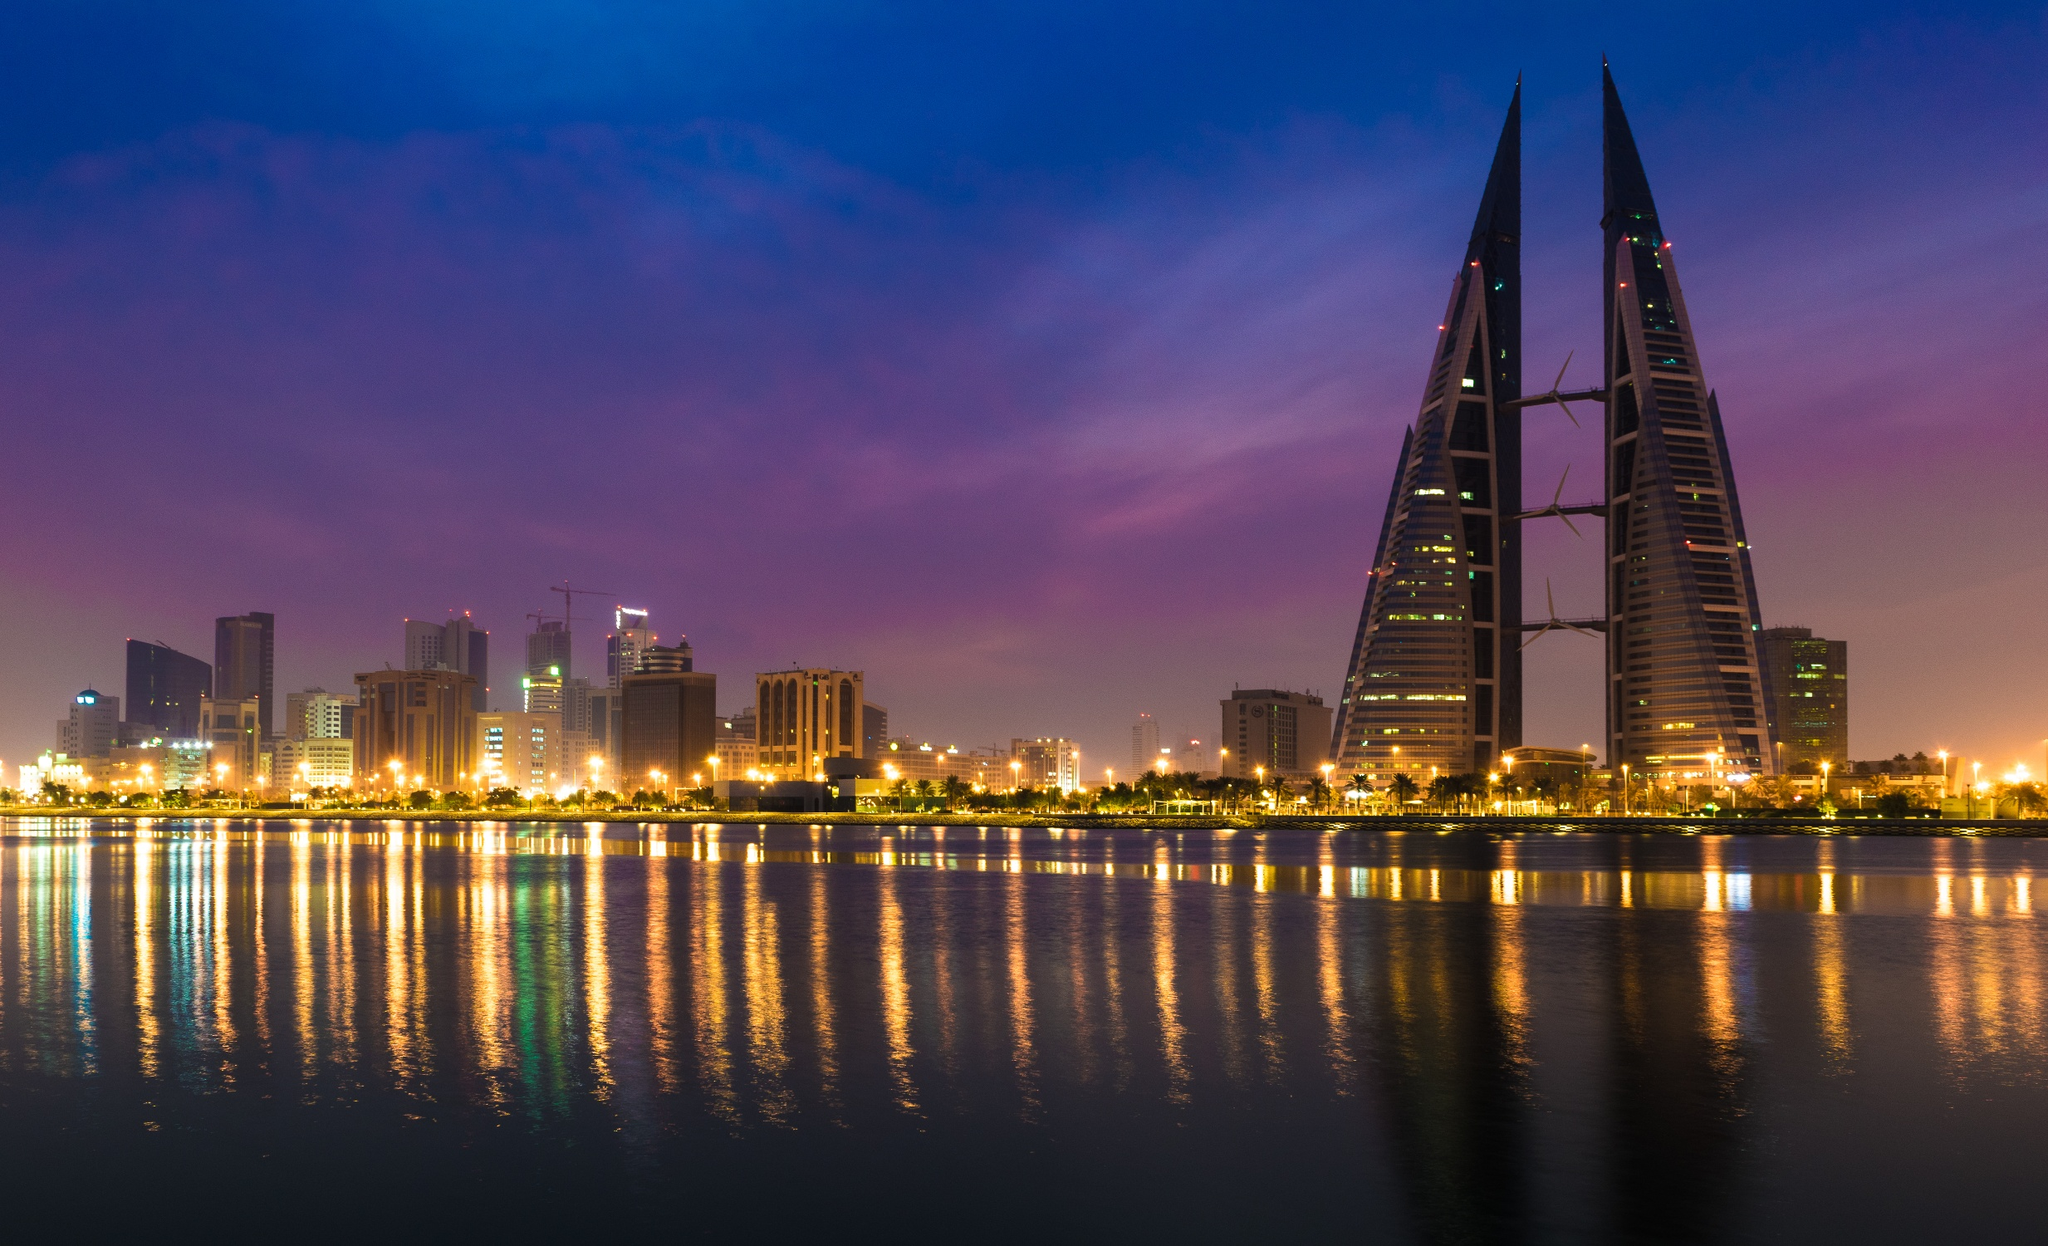How does the night setting of this image contribute to its overall mood? The night setting of this image significantly contributes to its tranquil and majestic mood. The deep blues and purples of the night sky contrast beautifully with the golden lights of the buildings, creating a serene yet impressive atmosphere. The reflection of the illuminated towers and city lights on the still water adds a sense of calmness and contemplation. The overall scene exudes a peaceful yet powerful ambiance, making it a captivating visual experience. Describe a realistic evening scenario that could be taking place in this view. On a typical evening, families and friends gather along the waterfront promenade, enjoying late-night coffee at nearby cafes. Couples stroll hand in hand, savoring the cool breeze and the picturesque view of the Bahrain World Trade Center shining brightly in the night. Office workers, having finished their day's work in the towering business district, find solace in the gentle reflection of city lights on the calm waters. Joggers and cyclists pass by, relishing the serene environment, while photographers capture the perfect shot of the illuminated skyline. Laughter, conversations, and the distant sounds of live music from a waterfront restaurant blend into a harmonious backdrop, encapsulating the essence of a peaceful and vibrant city night. Could a significant event in the city's history be tied to this location? Describe it. Yes, a significant event in the city's history could be tied to this location. Imagine a grand inauguration ceremony marking the completion of the Bahrain World Trade Center. This event drew dignitaries and citizens alike, symbolizing a new era of architectural prowess and sustainable development for Bahrain. As the sun set and the sky turned shades of twilight, the towers were illuminated for the first time, their lights reflecting off the calm water and symbolizing hope and prosperity. A spectacular fireworks display followed, lighting up the sky, and a ceremonial cutting of the ribbon by high officials was conducted amidst cheers and celebration. This evening was not just a celebration of a new landmark but also of Bahrain's leap towards a future of innovation and sustainability. The mood was euphoric, filled with pride and optimism, marking a historic milestone that would be remembered for generations to come. 